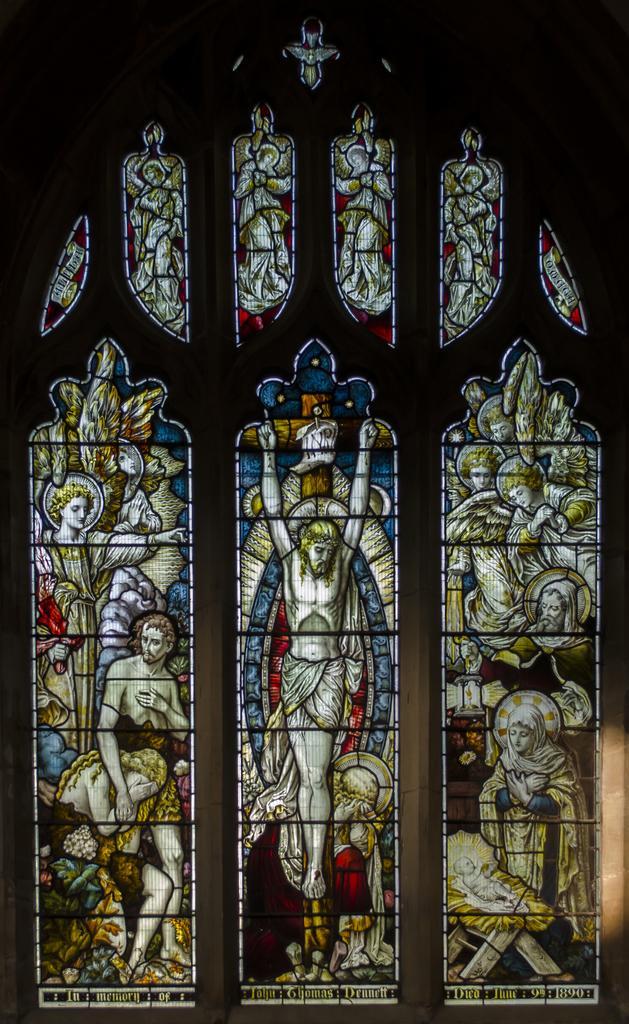Describe this image in one or two sentences. In this image we can see windows with design. 